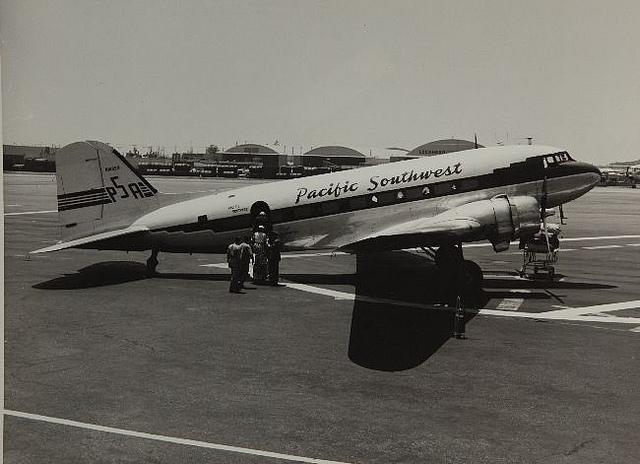What is written on the plane?
Quick response, please. Pacific southwest. What number is on the plane?
Concise answer only. 5. What type of plane is this?
Answer briefly. Commercial. Is this a Canadian plane?
Write a very short answer. No. What airline owns this plane?
Keep it brief. Pacific southwest. Is this plane an exhibit of some kind?
Keep it brief. No. What is the tail number of the farthest planet?
Concise answer only. 5. Where is the flight attendant?
Concise answer only. On plane. Is the photo colored?
Write a very short answer. No. Is this a small plane or large plane?
Keep it brief. Small. Are colors visible?
Answer briefly. No. What color is the tip of the plane's wing?
Quick response, please. White. Who owned this plane?
Answer briefly. Pacific southwest. What word is on the front?
Be succinct. Pacific southwest. How long is the plane?
Answer briefly. 100 feet. What decade was the photo taken in?
Short answer required. 1950's. What number is the passenger loader?
Quick response, please. 5. Is this plane going to depart?
Short answer required. Yes. What does it say on the side of the plane?
Keep it brief. Pacific southwest. Was this photo taken in the morning, at noon or at dusk?
Short answer required. Morning. What color is the W on the plane?
Write a very short answer. Black. How many shadows can you count?
Concise answer only. 1. 